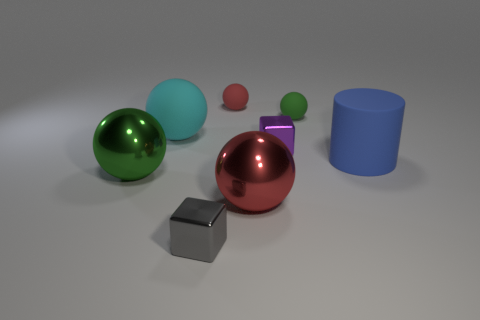How many large balls are the same color as the large matte cylinder?
Provide a short and direct response. 0. What material is the thing behind the small sphere that is right of the small purple block in front of the tiny green thing made of?
Your response must be concise. Rubber. How many yellow objects are either tiny rubber spheres or big matte things?
Provide a succinct answer. 0. There is a metal cube that is in front of the large metallic sphere that is on the left side of the large object that is behind the big cylinder; how big is it?
Provide a short and direct response. Small. What is the size of the other green thing that is the same shape as the green matte thing?
Your answer should be very brief. Large. What number of small things are either cyan metal cylinders or blue matte cylinders?
Your answer should be very brief. 0. Is the ball in front of the large green metallic ball made of the same material as the big object on the right side of the purple metallic object?
Ensure brevity in your answer.  No. There is a block that is right of the tiny red object; what is its material?
Keep it short and to the point. Metal. What number of metal objects are either big cylinders or balls?
Provide a succinct answer. 2. The big object behind the metal block behind the blue cylinder is what color?
Provide a succinct answer. Cyan. 